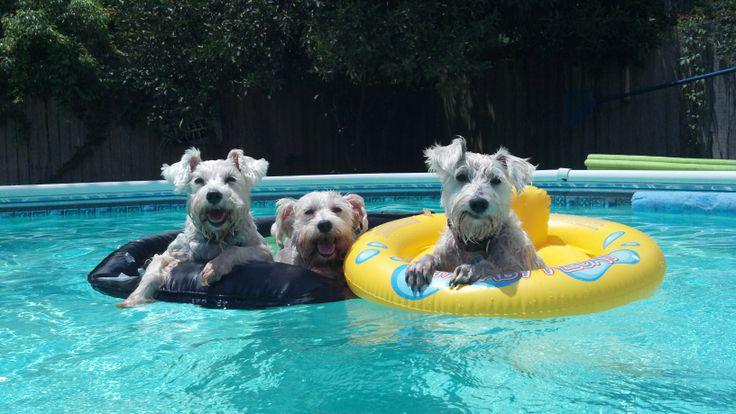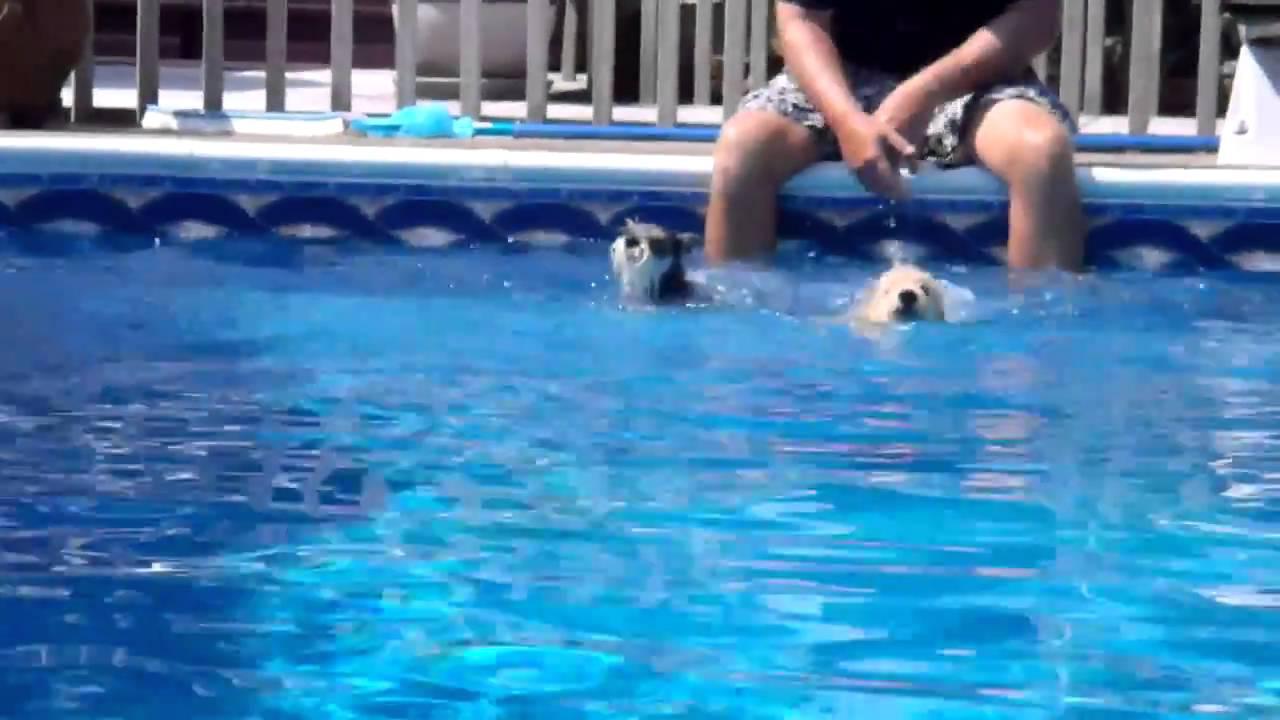The first image is the image on the left, the second image is the image on the right. Evaluate the accuracy of this statement regarding the images: "At least one of the dogs is on a floatation device.". Is it true? Answer yes or no. Yes. The first image is the image on the left, the second image is the image on the right. For the images shown, is this caption "An image shows a dog in a swim ring in a pool." true? Answer yes or no. Yes. 